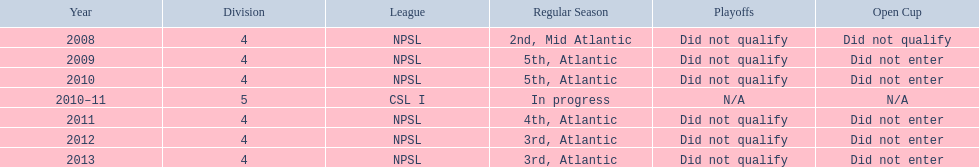What are the associations? NPSL, NPSL, NPSL, CSL I, NPSL, NPSL, NPSL. Among them, which association is not npsl? CSL I. Could you parse the entire table as a dict? {'header': ['Year', 'Division', 'League', 'Regular Season', 'Playoffs', 'Open Cup'], 'rows': [['2008', '4', 'NPSL', '2nd, Mid Atlantic', 'Did not qualify', 'Did not qualify'], ['2009', '4', 'NPSL', '5th, Atlantic', 'Did not qualify', 'Did not enter'], ['2010', '4', 'NPSL', '5th, Atlantic', 'Did not qualify', 'Did not enter'], ['2010–11', '5', 'CSL I', 'In progress', 'N/A', 'N/A'], ['2011', '4', 'NPSL', '4th, Atlantic', 'Did not qualify', 'Did not enter'], ['2012', '4', 'NPSL', '3rd, Atlantic', 'Did not qualify', 'Did not enter'], ['2013', '4', 'NPSL', '3rd, Atlantic', 'Did not qualify', 'Did not enter']]} 